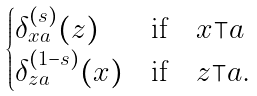<formula> <loc_0><loc_0><loc_500><loc_500>\begin{cases} \delta ^ { ( s ) } _ { x a } ( z ) & \text {if} \quad x \top a \\ \delta ^ { ( 1 - s ) } _ { z a } ( x ) & \text {if} \quad z \top a . \end{cases}</formula> 